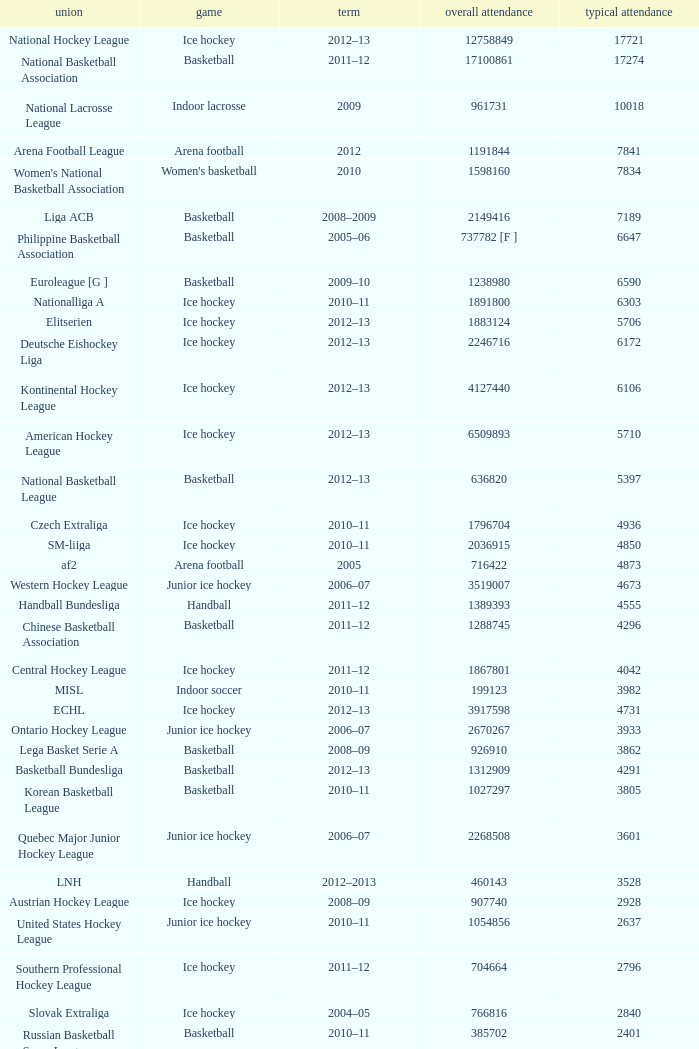What's the average attendance of the league with a total attendance of 2268508? 3601.0. 